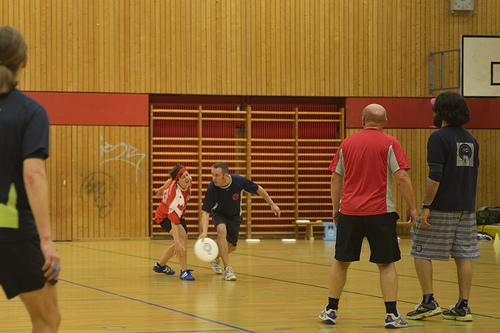Identify the primary subjects in the scene and the activity they appear to be participating in, using a casual tone. There's a bunch of folks having a good time playing frisbee in a gym with wooden walls. Some of 'em got basketball games going too. Narrate the action involving the frisbee using informal language. Yo, peeps are tossing around a cool white frisbee, having a blast. One of 'em's holding it with their right hand. Good times! Using a journalistic tone, describe the graffiti on the walls. In an urban-style indoor setting, graffiti adorns wooden walls, adding a touch of street art to the otherwise functional space. The colorful scrawls contribute to the lively, competitive atmosphere inside the gym. Write a concise scientific description of an object in the image and its interaction with another object. A large white plastic frisbee (23 cm x 23 cm) appears to be actively engaged in play between subjects, as evidenced by its position in the players' right hand (195 cm x 237 cm). Report the number of footwear and headwear items visible in a news reporter style. On the scene, we have observed a total of four notable footwear and headwear items. Among these are a woman's blue tennis shoe, a black cap, part of a red headgear, and a black sock. In a poetic manner, describe the woman's attire. Her sneakers blue as the skies at dawn. What are some visible sports-related elements using a technical writing style? There are several sports-related elements in the image such as - a black and white basketball goal mounted on a wall; a wooden gym floor, presumably waxed for improved performance; and the engagement of the subjects in frisbee and basketball, inferring physical activity. Describe the key components of the image in the form of a haiku. Graffiti on walls. What are the main colors of the man's outfit with striped shorts? The guy's rockin' plaid shorts and a red and gray short-sleeved shirt. Chic! 